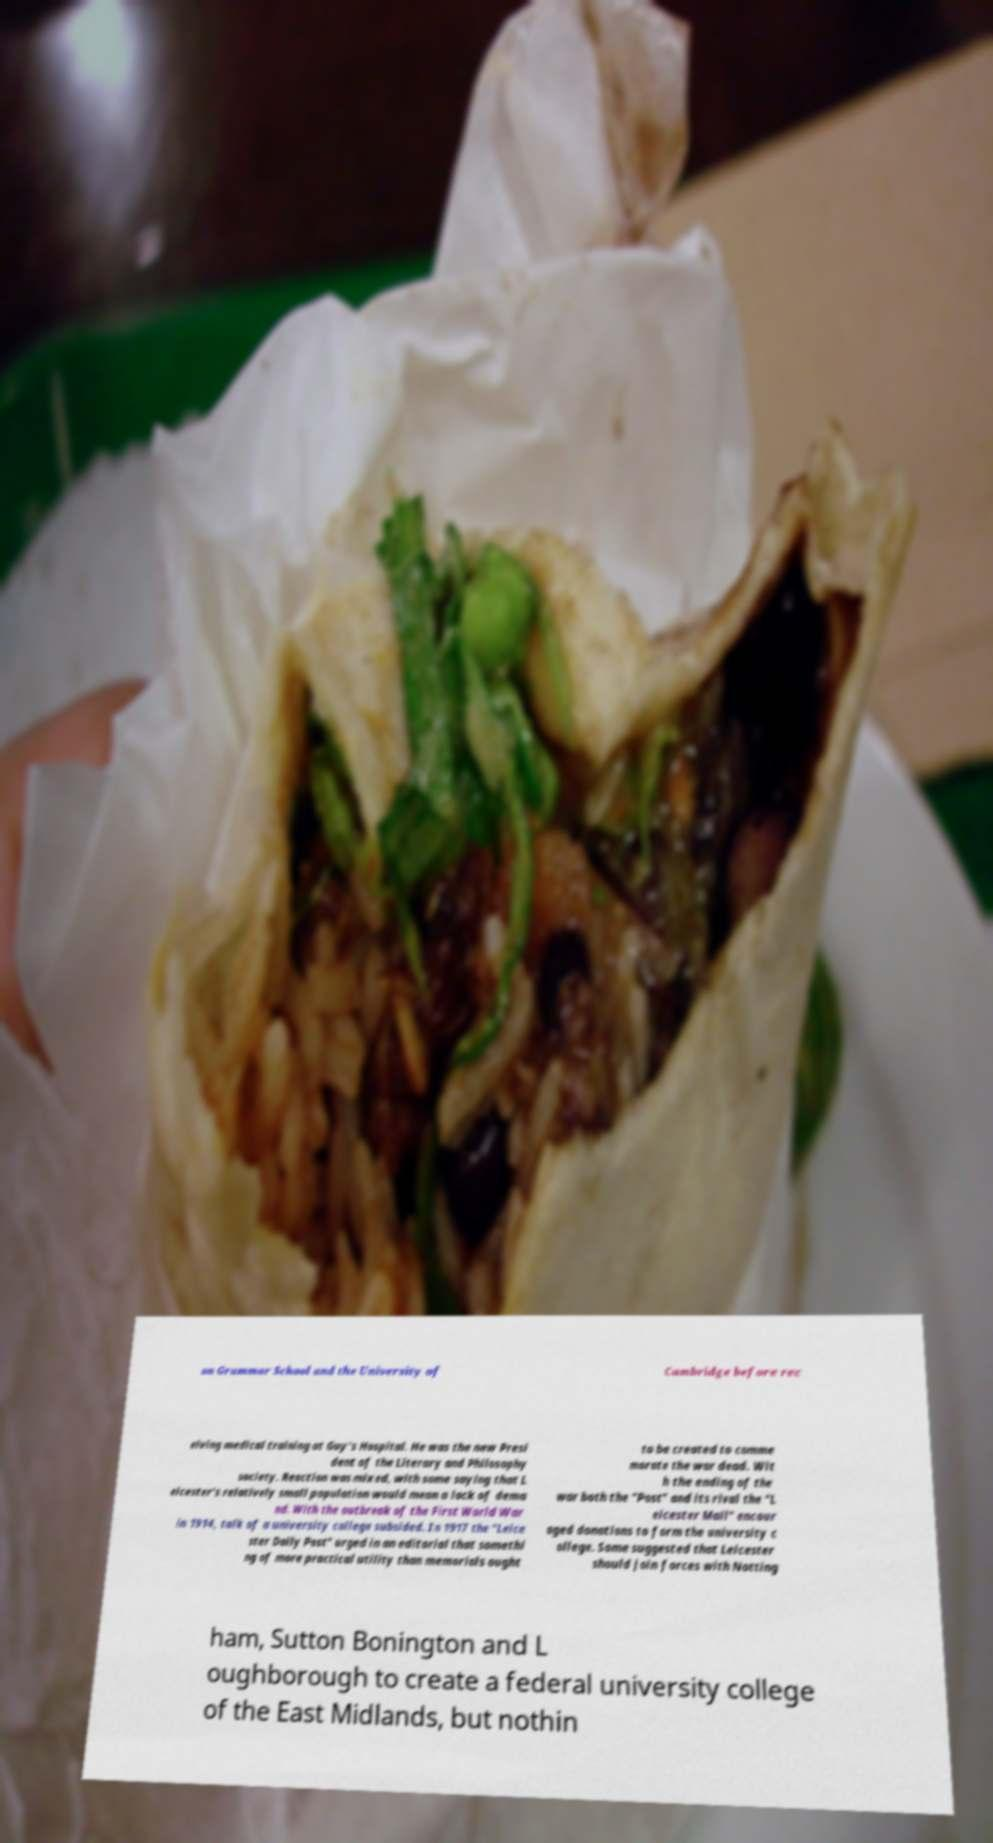Please read and relay the text visible in this image. What does it say? on Grammar School and the University of Cambridge before rec eiving medical training at Guy's Hospital. He was the new Presi dent of the Literary and Philosophy society. Reaction was mixed, with some saying that L eicester's relatively small population would mean a lack of dema nd. With the outbreak of the First World War in 1914, talk of a university college subsided. In 1917 the "Leice ster Daily Post" urged in an editorial that somethi ng of more practical utility than memorials ought to be created to comme morate the war dead. Wit h the ending of the war both the "Post" and its rival the "L eicester Mail" encour aged donations to form the university c ollege. Some suggested that Leicester should join forces with Notting ham, Sutton Bonington and L oughborough to create a federal university college of the East Midlands, but nothin 